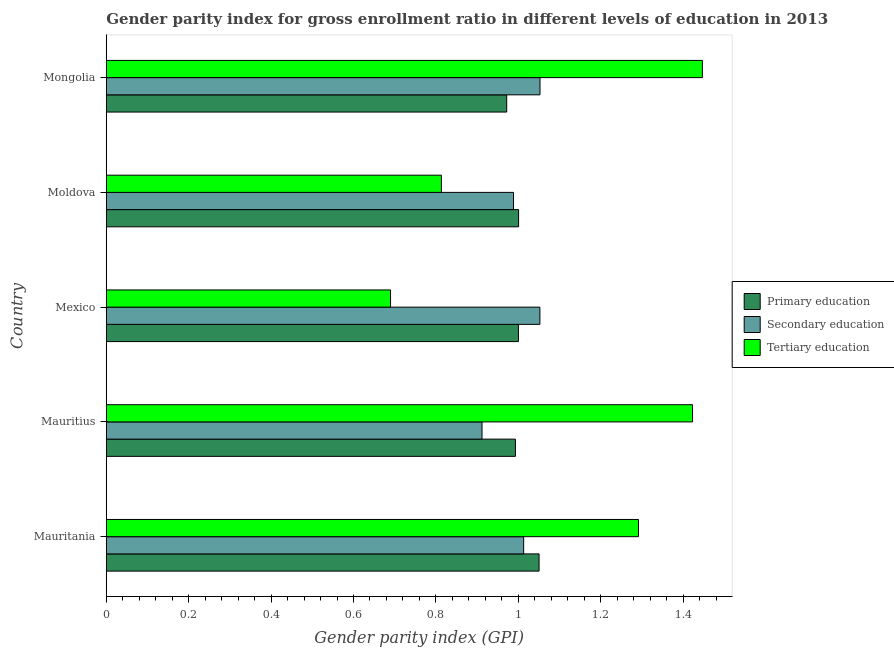How many different coloured bars are there?
Give a very brief answer. 3. How many groups of bars are there?
Provide a succinct answer. 5. Are the number of bars on each tick of the Y-axis equal?
Your answer should be very brief. Yes. How many bars are there on the 2nd tick from the top?
Provide a succinct answer. 3. How many bars are there on the 5th tick from the bottom?
Provide a succinct answer. 3. What is the label of the 2nd group of bars from the top?
Ensure brevity in your answer.  Moldova. In how many cases, is the number of bars for a given country not equal to the number of legend labels?
Your response must be concise. 0. What is the gender parity index in tertiary education in Moldova?
Offer a terse response. 0.81. Across all countries, what is the maximum gender parity index in secondary education?
Your response must be concise. 1.05. Across all countries, what is the minimum gender parity index in secondary education?
Provide a short and direct response. 0.91. In which country was the gender parity index in secondary education maximum?
Keep it short and to the point. Mongolia. In which country was the gender parity index in primary education minimum?
Provide a succinct answer. Mongolia. What is the total gender parity index in primary education in the graph?
Your response must be concise. 5.02. What is the difference between the gender parity index in secondary education in Moldova and the gender parity index in primary education in Mauritius?
Give a very brief answer. -0. What is the average gender parity index in tertiary education per country?
Offer a very short reply. 1.13. What is the difference between the gender parity index in secondary education and gender parity index in primary education in Mauritania?
Give a very brief answer. -0.04. What is the ratio of the gender parity index in tertiary education in Mauritania to that in Moldova?
Give a very brief answer. 1.59. Is the gender parity index in primary education in Mauritania less than that in Mongolia?
Offer a very short reply. No. What is the difference between the highest and the second highest gender parity index in primary education?
Your answer should be compact. 0.05. What is the difference between the highest and the lowest gender parity index in secondary education?
Keep it short and to the point. 0.14. In how many countries, is the gender parity index in secondary education greater than the average gender parity index in secondary education taken over all countries?
Ensure brevity in your answer.  3. Is the sum of the gender parity index in primary education in Mauritania and Mexico greater than the maximum gender parity index in tertiary education across all countries?
Ensure brevity in your answer.  Yes. What does the 2nd bar from the bottom in Mauritania represents?
Your answer should be compact. Secondary education. Is it the case that in every country, the sum of the gender parity index in primary education and gender parity index in secondary education is greater than the gender parity index in tertiary education?
Make the answer very short. Yes. Are the values on the major ticks of X-axis written in scientific E-notation?
Offer a very short reply. No. Does the graph contain grids?
Offer a terse response. No. Where does the legend appear in the graph?
Your response must be concise. Center right. How many legend labels are there?
Give a very brief answer. 3. How are the legend labels stacked?
Keep it short and to the point. Vertical. What is the title of the graph?
Give a very brief answer. Gender parity index for gross enrollment ratio in different levels of education in 2013. Does "Renewable sources" appear as one of the legend labels in the graph?
Provide a short and direct response. No. What is the label or title of the X-axis?
Give a very brief answer. Gender parity index (GPI). What is the label or title of the Y-axis?
Make the answer very short. Country. What is the Gender parity index (GPI) of Primary education in Mauritania?
Your answer should be very brief. 1.05. What is the Gender parity index (GPI) in Secondary education in Mauritania?
Your answer should be compact. 1.01. What is the Gender parity index (GPI) of Tertiary education in Mauritania?
Ensure brevity in your answer.  1.29. What is the Gender parity index (GPI) of Primary education in Mauritius?
Give a very brief answer. 0.99. What is the Gender parity index (GPI) in Secondary education in Mauritius?
Provide a short and direct response. 0.91. What is the Gender parity index (GPI) of Tertiary education in Mauritius?
Make the answer very short. 1.42. What is the Gender parity index (GPI) of Primary education in Mexico?
Ensure brevity in your answer.  1. What is the Gender parity index (GPI) in Secondary education in Mexico?
Your answer should be very brief. 1.05. What is the Gender parity index (GPI) in Tertiary education in Mexico?
Your answer should be compact. 0.69. What is the Gender parity index (GPI) of Primary education in Moldova?
Provide a succinct answer. 1. What is the Gender parity index (GPI) of Secondary education in Moldova?
Offer a terse response. 0.99. What is the Gender parity index (GPI) of Tertiary education in Moldova?
Provide a short and direct response. 0.81. What is the Gender parity index (GPI) in Primary education in Mongolia?
Keep it short and to the point. 0.97. What is the Gender parity index (GPI) of Secondary education in Mongolia?
Provide a short and direct response. 1.05. What is the Gender parity index (GPI) in Tertiary education in Mongolia?
Offer a very short reply. 1.45. Across all countries, what is the maximum Gender parity index (GPI) in Primary education?
Provide a succinct answer. 1.05. Across all countries, what is the maximum Gender parity index (GPI) in Secondary education?
Your answer should be very brief. 1.05. Across all countries, what is the maximum Gender parity index (GPI) in Tertiary education?
Keep it short and to the point. 1.45. Across all countries, what is the minimum Gender parity index (GPI) in Primary education?
Your answer should be compact. 0.97. Across all countries, what is the minimum Gender parity index (GPI) of Secondary education?
Give a very brief answer. 0.91. Across all countries, what is the minimum Gender parity index (GPI) of Tertiary education?
Keep it short and to the point. 0.69. What is the total Gender parity index (GPI) in Primary education in the graph?
Your answer should be compact. 5.02. What is the total Gender parity index (GPI) in Secondary education in the graph?
Your response must be concise. 5.02. What is the total Gender parity index (GPI) in Tertiary education in the graph?
Your answer should be very brief. 5.66. What is the difference between the Gender parity index (GPI) of Primary education in Mauritania and that in Mauritius?
Your answer should be very brief. 0.06. What is the difference between the Gender parity index (GPI) of Secondary education in Mauritania and that in Mauritius?
Provide a short and direct response. 0.1. What is the difference between the Gender parity index (GPI) in Tertiary education in Mauritania and that in Mauritius?
Offer a terse response. -0.13. What is the difference between the Gender parity index (GPI) in Primary education in Mauritania and that in Mexico?
Provide a short and direct response. 0.05. What is the difference between the Gender parity index (GPI) of Secondary education in Mauritania and that in Mexico?
Provide a short and direct response. -0.04. What is the difference between the Gender parity index (GPI) in Tertiary education in Mauritania and that in Mexico?
Provide a succinct answer. 0.6. What is the difference between the Gender parity index (GPI) of Primary education in Mauritania and that in Moldova?
Provide a short and direct response. 0.05. What is the difference between the Gender parity index (GPI) in Secondary education in Mauritania and that in Moldova?
Offer a very short reply. 0.02. What is the difference between the Gender parity index (GPI) of Tertiary education in Mauritania and that in Moldova?
Provide a short and direct response. 0.48. What is the difference between the Gender parity index (GPI) of Primary education in Mauritania and that in Mongolia?
Provide a succinct answer. 0.08. What is the difference between the Gender parity index (GPI) in Secondary education in Mauritania and that in Mongolia?
Provide a short and direct response. -0.04. What is the difference between the Gender parity index (GPI) of Tertiary education in Mauritania and that in Mongolia?
Your answer should be compact. -0.15. What is the difference between the Gender parity index (GPI) in Primary education in Mauritius and that in Mexico?
Give a very brief answer. -0.01. What is the difference between the Gender parity index (GPI) of Secondary education in Mauritius and that in Mexico?
Your answer should be very brief. -0.14. What is the difference between the Gender parity index (GPI) in Tertiary education in Mauritius and that in Mexico?
Your answer should be compact. 0.73. What is the difference between the Gender parity index (GPI) of Primary education in Mauritius and that in Moldova?
Offer a terse response. -0.01. What is the difference between the Gender parity index (GPI) in Secondary education in Mauritius and that in Moldova?
Give a very brief answer. -0.08. What is the difference between the Gender parity index (GPI) of Tertiary education in Mauritius and that in Moldova?
Give a very brief answer. 0.61. What is the difference between the Gender parity index (GPI) of Primary education in Mauritius and that in Mongolia?
Make the answer very short. 0.02. What is the difference between the Gender parity index (GPI) in Secondary education in Mauritius and that in Mongolia?
Make the answer very short. -0.14. What is the difference between the Gender parity index (GPI) of Tertiary education in Mauritius and that in Mongolia?
Offer a terse response. -0.02. What is the difference between the Gender parity index (GPI) of Primary education in Mexico and that in Moldova?
Provide a short and direct response. -0. What is the difference between the Gender parity index (GPI) of Secondary education in Mexico and that in Moldova?
Offer a very short reply. 0.06. What is the difference between the Gender parity index (GPI) in Tertiary education in Mexico and that in Moldova?
Keep it short and to the point. -0.12. What is the difference between the Gender parity index (GPI) of Primary education in Mexico and that in Mongolia?
Provide a succinct answer. 0.03. What is the difference between the Gender parity index (GPI) in Secondary education in Mexico and that in Mongolia?
Your response must be concise. -0. What is the difference between the Gender parity index (GPI) of Tertiary education in Mexico and that in Mongolia?
Give a very brief answer. -0.76. What is the difference between the Gender parity index (GPI) of Primary education in Moldova and that in Mongolia?
Your answer should be very brief. 0.03. What is the difference between the Gender parity index (GPI) in Secondary education in Moldova and that in Mongolia?
Offer a terse response. -0.06. What is the difference between the Gender parity index (GPI) in Tertiary education in Moldova and that in Mongolia?
Your answer should be compact. -0.63. What is the difference between the Gender parity index (GPI) of Primary education in Mauritania and the Gender parity index (GPI) of Secondary education in Mauritius?
Your answer should be compact. 0.14. What is the difference between the Gender parity index (GPI) in Primary education in Mauritania and the Gender parity index (GPI) in Tertiary education in Mauritius?
Give a very brief answer. -0.37. What is the difference between the Gender parity index (GPI) of Secondary education in Mauritania and the Gender parity index (GPI) of Tertiary education in Mauritius?
Ensure brevity in your answer.  -0.41. What is the difference between the Gender parity index (GPI) of Primary education in Mauritania and the Gender parity index (GPI) of Secondary education in Mexico?
Your answer should be very brief. -0. What is the difference between the Gender parity index (GPI) in Primary education in Mauritania and the Gender parity index (GPI) in Tertiary education in Mexico?
Provide a short and direct response. 0.36. What is the difference between the Gender parity index (GPI) in Secondary education in Mauritania and the Gender parity index (GPI) in Tertiary education in Mexico?
Provide a short and direct response. 0.32. What is the difference between the Gender parity index (GPI) in Primary education in Mauritania and the Gender parity index (GPI) in Secondary education in Moldova?
Offer a terse response. 0.06. What is the difference between the Gender parity index (GPI) in Primary education in Mauritania and the Gender parity index (GPI) in Tertiary education in Moldova?
Provide a succinct answer. 0.24. What is the difference between the Gender parity index (GPI) of Secondary education in Mauritania and the Gender parity index (GPI) of Tertiary education in Moldova?
Provide a short and direct response. 0.2. What is the difference between the Gender parity index (GPI) in Primary education in Mauritania and the Gender parity index (GPI) in Secondary education in Mongolia?
Make the answer very short. -0. What is the difference between the Gender parity index (GPI) in Primary education in Mauritania and the Gender parity index (GPI) in Tertiary education in Mongolia?
Your answer should be very brief. -0.4. What is the difference between the Gender parity index (GPI) of Secondary education in Mauritania and the Gender parity index (GPI) of Tertiary education in Mongolia?
Offer a very short reply. -0.43. What is the difference between the Gender parity index (GPI) in Primary education in Mauritius and the Gender parity index (GPI) in Secondary education in Mexico?
Your answer should be very brief. -0.06. What is the difference between the Gender parity index (GPI) of Primary education in Mauritius and the Gender parity index (GPI) of Tertiary education in Mexico?
Keep it short and to the point. 0.3. What is the difference between the Gender parity index (GPI) in Secondary education in Mauritius and the Gender parity index (GPI) in Tertiary education in Mexico?
Offer a very short reply. 0.22. What is the difference between the Gender parity index (GPI) of Primary education in Mauritius and the Gender parity index (GPI) of Secondary education in Moldova?
Provide a succinct answer. 0. What is the difference between the Gender parity index (GPI) in Primary education in Mauritius and the Gender parity index (GPI) in Tertiary education in Moldova?
Ensure brevity in your answer.  0.18. What is the difference between the Gender parity index (GPI) of Secondary education in Mauritius and the Gender parity index (GPI) of Tertiary education in Moldova?
Offer a very short reply. 0.1. What is the difference between the Gender parity index (GPI) in Primary education in Mauritius and the Gender parity index (GPI) in Secondary education in Mongolia?
Provide a short and direct response. -0.06. What is the difference between the Gender parity index (GPI) of Primary education in Mauritius and the Gender parity index (GPI) of Tertiary education in Mongolia?
Give a very brief answer. -0.45. What is the difference between the Gender parity index (GPI) of Secondary education in Mauritius and the Gender parity index (GPI) of Tertiary education in Mongolia?
Give a very brief answer. -0.53. What is the difference between the Gender parity index (GPI) of Primary education in Mexico and the Gender parity index (GPI) of Secondary education in Moldova?
Offer a terse response. 0.01. What is the difference between the Gender parity index (GPI) in Primary education in Mexico and the Gender parity index (GPI) in Tertiary education in Moldova?
Provide a succinct answer. 0.19. What is the difference between the Gender parity index (GPI) in Secondary education in Mexico and the Gender parity index (GPI) in Tertiary education in Moldova?
Offer a very short reply. 0.24. What is the difference between the Gender parity index (GPI) of Primary education in Mexico and the Gender parity index (GPI) of Secondary education in Mongolia?
Provide a short and direct response. -0.05. What is the difference between the Gender parity index (GPI) of Primary education in Mexico and the Gender parity index (GPI) of Tertiary education in Mongolia?
Your answer should be very brief. -0.45. What is the difference between the Gender parity index (GPI) of Secondary education in Mexico and the Gender parity index (GPI) of Tertiary education in Mongolia?
Offer a terse response. -0.39. What is the difference between the Gender parity index (GPI) of Primary education in Moldova and the Gender parity index (GPI) of Secondary education in Mongolia?
Your response must be concise. -0.05. What is the difference between the Gender parity index (GPI) in Primary education in Moldova and the Gender parity index (GPI) in Tertiary education in Mongolia?
Make the answer very short. -0.45. What is the difference between the Gender parity index (GPI) of Secondary education in Moldova and the Gender parity index (GPI) of Tertiary education in Mongolia?
Provide a short and direct response. -0.46. What is the average Gender parity index (GPI) in Primary education per country?
Ensure brevity in your answer.  1. What is the average Gender parity index (GPI) in Tertiary education per country?
Your answer should be compact. 1.13. What is the difference between the Gender parity index (GPI) in Primary education and Gender parity index (GPI) in Secondary education in Mauritania?
Provide a succinct answer. 0.04. What is the difference between the Gender parity index (GPI) of Primary education and Gender parity index (GPI) of Tertiary education in Mauritania?
Make the answer very short. -0.24. What is the difference between the Gender parity index (GPI) of Secondary education and Gender parity index (GPI) of Tertiary education in Mauritania?
Offer a very short reply. -0.28. What is the difference between the Gender parity index (GPI) in Primary education and Gender parity index (GPI) in Secondary education in Mauritius?
Make the answer very short. 0.08. What is the difference between the Gender parity index (GPI) of Primary education and Gender parity index (GPI) of Tertiary education in Mauritius?
Offer a terse response. -0.43. What is the difference between the Gender parity index (GPI) in Secondary education and Gender parity index (GPI) in Tertiary education in Mauritius?
Make the answer very short. -0.51. What is the difference between the Gender parity index (GPI) in Primary education and Gender parity index (GPI) in Secondary education in Mexico?
Offer a terse response. -0.05. What is the difference between the Gender parity index (GPI) in Primary education and Gender parity index (GPI) in Tertiary education in Mexico?
Provide a succinct answer. 0.31. What is the difference between the Gender parity index (GPI) of Secondary education and Gender parity index (GPI) of Tertiary education in Mexico?
Provide a succinct answer. 0.36. What is the difference between the Gender parity index (GPI) in Primary education and Gender parity index (GPI) in Secondary education in Moldova?
Ensure brevity in your answer.  0.01. What is the difference between the Gender parity index (GPI) of Primary education and Gender parity index (GPI) of Tertiary education in Moldova?
Your answer should be compact. 0.19. What is the difference between the Gender parity index (GPI) in Secondary education and Gender parity index (GPI) in Tertiary education in Moldova?
Provide a succinct answer. 0.18. What is the difference between the Gender parity index (GPI) of Primary education and Gender parity index (GPI) of Secondary education in Mongolia?
Provide a short and direct response. -0.08. What is the difference between the Gender parity index (GPI) in Primary education and Gender parity index (GPI) in Tertiary education in Mongolia?
Provide a short and direct response. -0.47. What is the difference between the Gender parity index (GPI) in Secondary education and Gender parity index (GPI) in Tertiary education in Mongolia?
Provide a short and direct response. -0.39. What is the ratio of the Gender parity index (GPI) of Primary education in Mauritania to that in Mauritius?
Give a very brief answer. 1.06. What is the ratio of the Gender parity index (GPI) in Secondary education in Mauritania to that in Mauritius?
Your response must be concise. 1.11. What is the ratio of the Gender parity index (GPI) in Tertiary education in Mauritania to that in Mauritius?
Offer a very short reply. 0.91. What is the ratio of the Gender parity index (GPI) of Primary education in Mauritania to that in Mexico?
Give a very brief answer. 1.05. What is the ratio of the Gender parity index (GPI) of Secondary education in Mauritania to that in Mexico?
Your answer should be very brief. 0.96. What is the ratio of the Gender parity index (GPI) in Tertiary education in Mauritania to that in Mexico?
Provide a succinct answer. 1.87. What is the ratio of the Gender parity index (GPI) of Primary education in Mauritania to that in Moldova?
Keep it short and to the point. 1.05. What is the ratio of the Gender parity index (GPI) of Secondary education in Mauritania to that in Moldova?
Offer a terse response. 1.02. What is the ratio of the Gender parity index (GPI) of Tertiary education in Mauritania to that in Moldova?
Offer a terse response. 1.59. What is the ratio of the Gender parity index (GPI) of Primary education in Mauritania to that in Mongolia?
Offer a terse response. 1.08. What is the ratio of the Gender parity index (GPI) of Secondary education in Mauritania to that in Mongolia?
Keep it short and to the point. 0.96. What is the ratio of the Gender parity index (GPI) in Tertiary education in Mauritania to that in Mongolia?
Offer a very short reply. 0.89. What is the ratio of the Gender parity index (GPI) in Primary education in Mauritius to that in Mexico?
Offer a very short reply. 0.99. What is the ratio of the Gender parity index (GPI) in Secondary education in Mauritius to that in Mexico?
Your answer should be very brief. 0.87. What is the ratio of the Gender parity index (GPI) in Tertiary education in Mauritius to that in Mexico?
Provide a short and direct response. 2.06. What is the ratio of the Gender parity index (GPI) in Secondary education in Mauritius to that in Moldova?
Keep it short and to the point. 0.92. What is the ratio of the Gender parity index (GPI) in Tertiary education in Mauritius to that in Moldova?
Your response must be concise. 1.75. What is the ratio of the Gender parity index (GPI) of Primary education in Mauritius to that in Mongolia?
Give a very brief answer. 1.02. What is the ratio of the Gender parity index (GPI) in Secondary education in Mauritius to that in Mongolia?
Your response must be concise. 0.87. What is the ratio of the Gender parity index (GPI) of Tertiary education in Mauritius to that in Mongolia?
Keep it short and to the point. 0.98. What is the ratio of the Gender parity index (GPI) in Primary education in Mexico to that in Moldova?
Your answer should be very brief. 1. What is the ratio of the Gender parity index (GPI) of Secondary education in Mexico to that in Moldova?
Make the answer very short. 1.06. What is the ratio of the Gender parity index (GPI) of Tertiary education in Mexico to that in Moldova?
Your answer should be very brief. 0.85. What is the ratio of the Gender parity index (GPI) in Primary education in Mexico to that in Mongolia?
Offer a terse response. 1.03. What is the ratio of the Gender parity index (GPI) of Secondary education in Mexico to that in Mongolia?
Provide a succinct answer. 1. What is the ratio of the Gender parity index (GPI) of Tertiary education in Mexico to that in Mongolia?
Ensure brevity in your answer.  0.48. What is the ratio of the Gender parity index (GPI) of Primary education in Moldova to that in Mongolia?
Your response must be concise. 1.03. What is the ratio of the Gender parity index (GPI) in Secondary education in Moldova to that in Mongolia?
Offer a very short reply. 0.94. What is the ratio of the Gender parity index (GPI) of Tertiary education in Moldova to that in Mongolia?
Offer a terse response. 0.56. What is the difference between the highest and the second highest Gender parity index (GPI) of Primary education?
Provide a short and direct response. 0.05. What is the difference between the highest and the second highest Gender parity index (GPI) of Secondary education?
Provide a succinct answer. 0. What is the difference between the highest and the second highest Gender parity index (GPI) in Tertiary education?
Offer a very short reply. 0.02. What is the difference between the highest and the lowest Gender parity index (GPI) of Primary education?
Offer a very short reply. 0.08. What is the difference between the highest and the lowest Gender parity index (GPI) of Secondary education?
Give a very brief answer. 0.14. What is the difference between the highest and the lowest Gender parity index (GPI) in Tertiary education?
Make the answer very short. 0.76. 